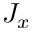<formula> <loc_0><loc_0><loc_500><loc_500>J _ { x }</formula> 